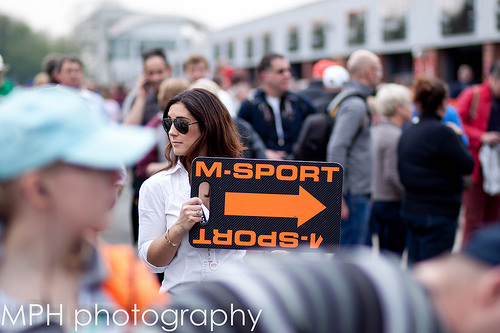<image>
Is there a woman behind the sign? Yes. From this viewpoint, the woman is positioned behind the sign, with the sign partially or fully occluding the woman. Where is the sign in relation to the woman? Is it in front of the woman? Yes. The sign is positioned in front of the woman, appearing closer to the camera viewpoint. 